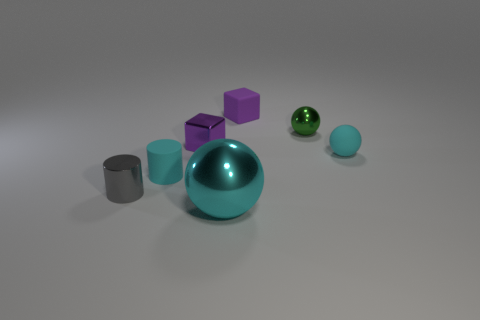Subtract all balls. How many objects are left? 4 Subtract 1 cylinders. How many cylinders are left? 1 Subtract all yellow blocks. Subtract all red balls. How many blocks are left? 2 Subtract all brown spheres. How many cyan cylinders are left? 1 Subtract all purple blocks. Subtract all spheres. How many objects are left? 2 Add 7 cyan rubber cylinders. How many cyan rubber cylinders are left? 8 Add 3 small green things. How many small green things exist? 4 Add 2 large green metallic cylinders. How many objects exist? 9 Subtract all cyan balls. How many balls are left? 1 Subtract all cyan metal spheres. How many spheres are left? 2 